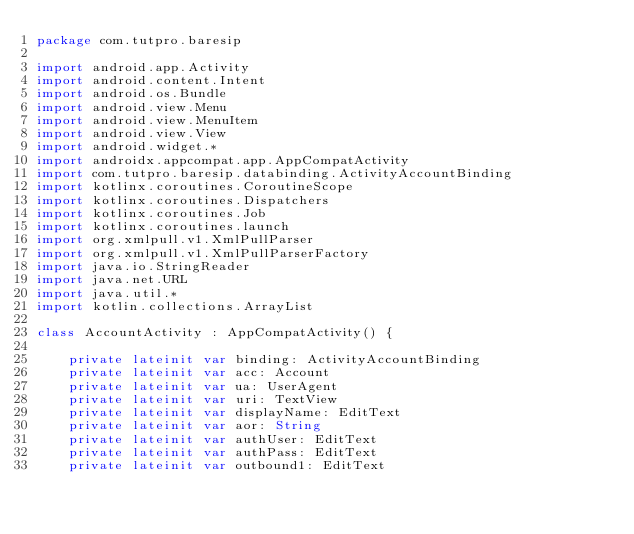<code> <loc_0><loc_0><loc_500><loc_500><_Kotlin_>package com.tutpro.baresip

import android.app.Activity
import android.content.Intent
import android.os.Bundle
import android.view.Menu
import android.view.MenuItem
import android.view.View
import android.widget.*
import androidx.appcompat.app.AppCompatActivity
import com.tutpro.baresip.databinding.ActivityAccountBinding
import kotlinx.coroutines.CoroutineScope
import kotlinx.coroutines.Dispatchers
import kotlinx.coroutines.Job
import kotlinx.coroutines.launch
import org.xmlpull.v1.XmlPullParser
import org.xmlpull.v1.XmlPullParserFactory
import java.io.StringReader
import java.net.URL
import java.util.*
import kotlin.collections.ArrayList

class AccountActivity : AppCompatActivity() {

    private lateinit var binding: ActivityAccountBinding
    private lateinit var acc: Account
    private lateinit var ua: UserAgent
    private lateinit var uri: TextView
    private lateinit var displayName: EditText
    private lateinit var aor: String
    private lateinit var authUser: EditText
    private lateinit var authPass: EditText
    private lateinit var outbound1: EditText</code> 